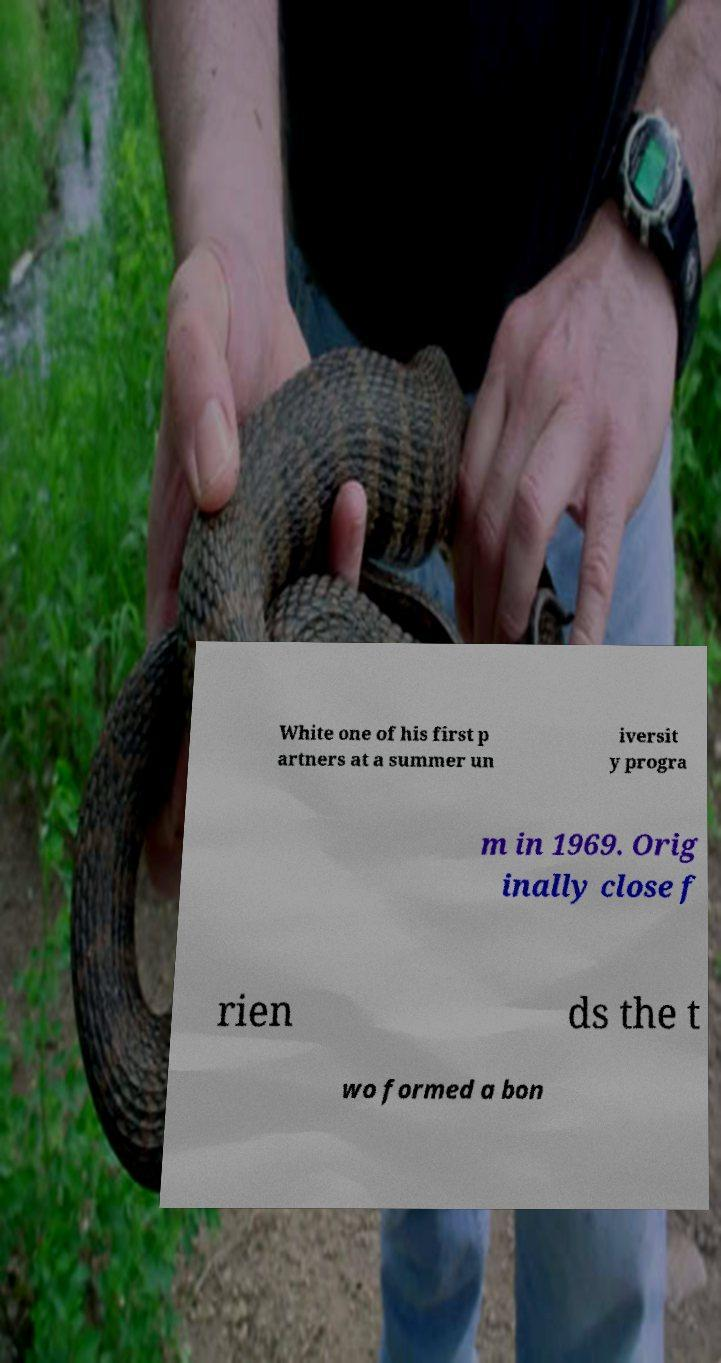Please read and relay the text visible in this image. What does it say? White one of his first p artners at a summer un iversit y progra m in 1969. Orig inally close f rien ds the t wo formed a bon 